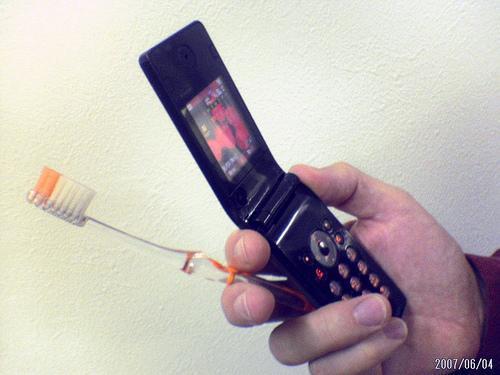How many skateboards are visible?
Give a very brief answer. 0. 